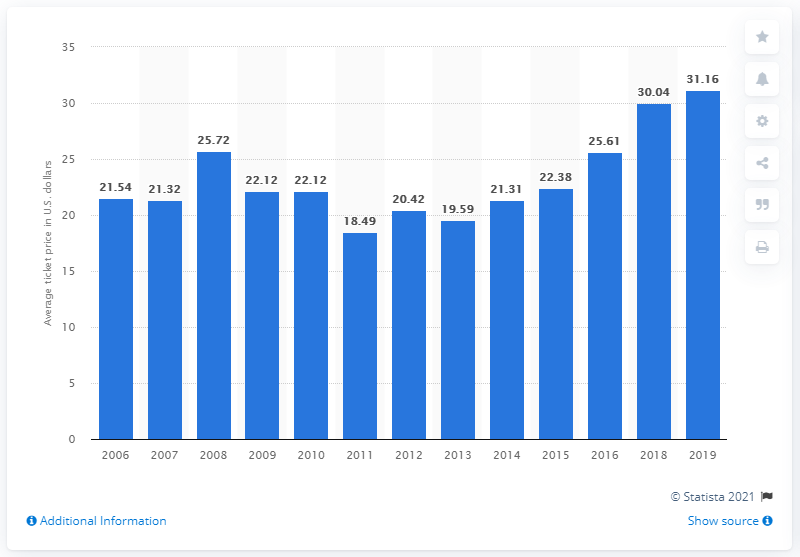Draw attention to some important aspects in this diagram. The average ticket price for Cleveland Indians games in 2019 was $31.16. 